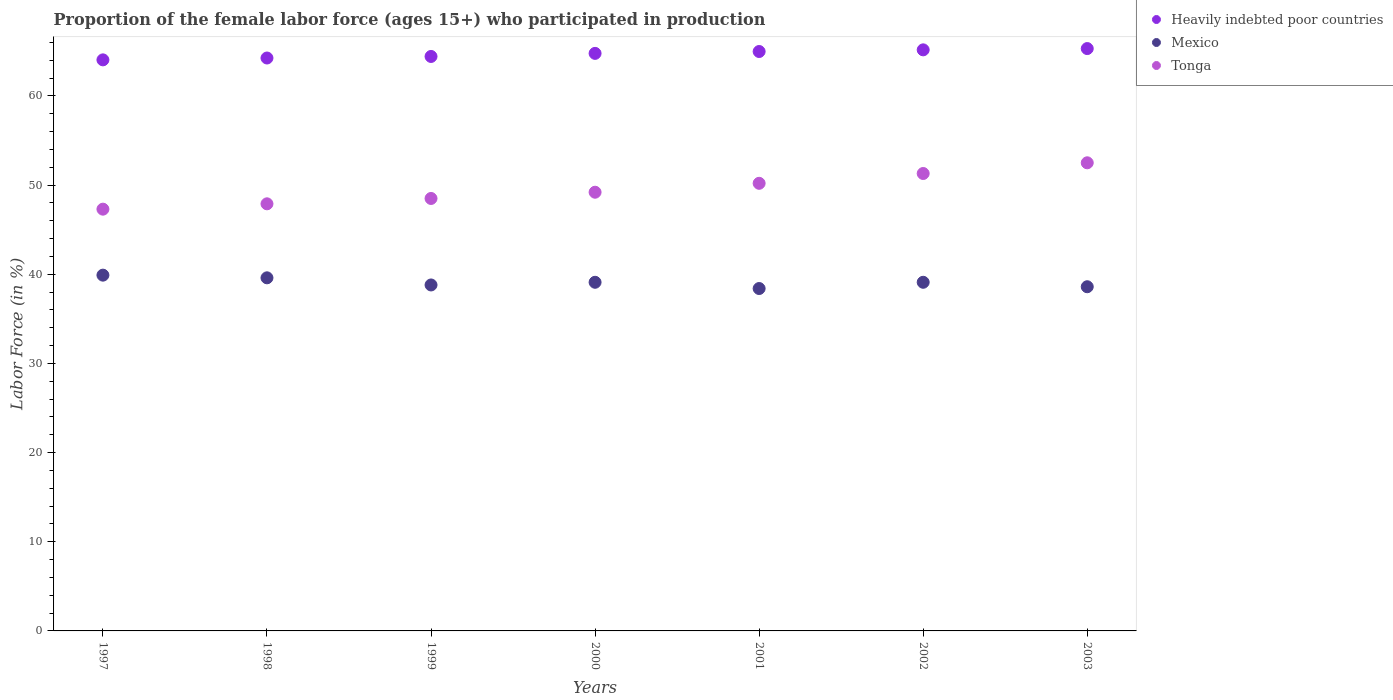Is the number of dotlines equal to the number of legend labels?
Provide a short and direct response. Yes. What is the proportion of the female labor force who participated in production in Tonga in 2002?
Offer a terse response. 51.3. Across all years, what is the maximum proportion of the female labor force who participated in production in Tonga?
Give a very brief answer. 52.5. Across all years, what is the minimum proportion of the female labor force who participated in production in Mexico?
Your answer should be compact. 38.4. What is the total proportion of the female labor force who participated in production in Heavily indebted poor countries in the graph?
Give a very brief answer. 452.95. What is the difference between the proportion of the female labor force who participated in production in Heavily indebted poor countries in 2000 and that in 2002?
Your answer should be compact. -0.4. What is the difference between the proportion of the female labor force who participated in production in Heavily indebted poor countries in 2001 and the proportion of the female labor force who participated in production in Tonga in 2000?
Give a very brief answer. 15.78. What is the average proportion of the female labor force who participated in production in Tonga per year?
Offer a terse response. 49.56. In the year 2000, what is the difference between the proportion of the female labor force who participated in production in Tonga and proportion of the female labor force who participated in production in Heavily indebted poor countries?
Provide a succinct answer. -15.57. In how many years, is the proportion of the female labor force who participated in production in Mexico greater than 36 %?
Provide a short and direct response. 7. What is the ratio of the proportion of the female labor force who participated in production in Tonga in 1999 to that in 2000?
Ensure brevity in your answer.  0.99. Is the proportion of the female labor force who participated in production in Tonga in 2001 less than that in 2003?
Offer a very short reply. Yes. Is the difference between the proportion of the female labor force who participated in production in Tonga in 1998 and 1999 greater than the difference between the proportion of the female labor force who participated in production in Heavily indebted poor countries in 1998 and 1999?
Make the answer very short. No. What is the difference between the highest and the second highest proportion of the female labor force who participated in production in Mexico?
Your answer should be very brief. 0.3. What is the difference between the highest and the lowest proportion of the female labor force who participated in production in Heavily indebted poor countries?
Provide a short and direct response. 1.27. In how many years, is the proportion of the female labor force who participated in production in Mexico greater than the average proportion of the female labor force who participated in production in Mexico taken over all years?
Make the answer very short. 4. How many dotlines are there?
Your response must be concise. 3. Are the values on the major ticks of Y-axis written in scientific E-notation?
Provide a short and direct response. No. Does the graph contain any zero values?
Your answer should be compact. No. Where does the legend appear in the graph?
Your response must be concise. Top right. How are the legend labels stacked?
Your response must be concise. Vertical. What is the title of the graph?
Make the answer very short. Proportion of the female labor force (ages 15+) who participated in production. What is the Labor Force (in %) in Heavily indebted poor countries in 1997?
Your answer should be very brief. 64.04. What is the Labor Force (in %) of Mexico in 1997?
Keep it short and to the point. 39.9. What is the Labor Force (in %) in Tonga in 1997?
Offer a very short reply. 47.3. What is the Labor Force (in %) of Heavily indebted poor countries in 1998?
Ensure brevity in your answer.  64.25. What is the Labor Force (in %) in Mexico in 1998?
Your answer should be very brief. 39.6. What is the Labor Force (in %) of Tonga in 1998?
Ensure brevity in your answer.  47.9. What is the Labor Force (in %) of Heavily indebted poor countries in 1999?
Provide a short and direct response. 64.43. What is the Labor Force (in %) of Mexico in 1999?
Your answer should be very brief. 38.8. What is the Labor Force (in %) of Tonga in 1999?
Offer a terse response. 48.5. What is the Labor Force (in %) in Heavily indebted poor countries in 2000?
Keep it short and to the point. 64.77. What is the Labor Force (in %) of Mexico in 2000?
Your answer should be very brief. 39.1. What is the Labor Force (in %) of Tonga in 2000?
Your answer should be very brief. 49.2. What is the Labor Force (in %) in Heavily indebted poor countries in 2001?
Give a very brief answer. 64.98. What is the Labor Force (in %) in Mexico in 2001?
Your answer should be compact. 38.4. What is the Labor Force (in %) in Tonga in 2001?
Your response must be concise. 50.2. What is the Labor Force (in %) in Heavily indebted poor countries in 2002?
Give a very brief answer. 65.17. What is the Labor Force (in %) of Mexico in 2002?
Provide a succinct answer. 39.1. What is the Labor Force (in %) of Tonga in 2002?
Give a very brief answer. 51.3. What is the Labor Force (in %) in Heavily indebted poor countries in 2003?
Your response must be concise. 65.31. What is the Labor Force (in %) of Mexico in 2003?
Provide a short and direct response. 38.6. What is the Labor Force (in %) of Tonga in 2003?
Provide a succinct answer. 52.5. Across all years, what is the maximum Labor Force (in %) of Heavily indebted poor countries?
Provide a short and direct response. 65.31. Across all years, what is the maximum Labor Force (in %) of Mexico?
Your answer should be compact. 39.9. Across all years, what is the maximum Labor Force (in %) of Tonga?
Give a very brief answer. 52.5. Across all years, what is the minimum Labor Force (in %) in Heavily indebted poor countries?
Offer a terse response. 64.04. Across all years, what is the minimum Labor Force (in %) in Mexico?
Offer a terse response. 38.4. Across all years, what is the minimum Labor Force (in %) in Tonga?
Make the answer very short. 47.3. What is the total Labor Force (in %) of Heavily indebted poor countries in the graph?
Ensure brevity in your answer.  452.95. What is the total Labor Force (in %) in Mexico in the graph?
Your response must be concise. 273.5. What is the total Labor Force (in %) of Tonga in the graph?
Your answer should be very brief. 346.9. What is the difference between the Labor Force (in %) of Heavily indebted poor countries in 1997 and that in 1998?
Provide a succinct answer. -0.21. What is the difference between the Labor Force (in %) of Tonga in 1997 and that in 1998?
Make the answer very short. -0.6. What is the difference between the Labor Force (in %) in Heavily indebted poor countries in 1997 and that in 1999?
Your response must be concise. -0.38. What is the difference between the Labor Force (in %) of Mexico in 1997 and that in 1999?
Ensure brevity in your answer.  1.1. What is the difference between the Labor Force (in %) in Heavily indebted poor countries in 1997 and that in 2000?
Offer a terse response. -0.73. What is the difference between the Labor Force (in %) in Tonga in 1997 and that in 2000?
Give a very brief answer. -1.9. What is the difference between the Labor Force (in %) in Heavily indebted poor countries in 1997 and that in 2001?
Make the answer very short. -0.94. What is the difference between the Labor Force (in %) in Mexico in 1997 and that in 2001?
Make the answer very short. 1.5. What is the difference between the Labor Force (in %) of Heavily indebted poor countries in 1997 and that in 2002?
Offer a very short reply. -1.12. What is the difference between the Labor Force (in %) of Mexico in 1997 and that in 2002?
Your response must be concise. 0.8. What is the difference between the Labor Force (in %) in Tonga in 1997 and that in 2002?
Make the answer very short. -4. What is the difference between the Labor Force (in %) in Heavily indebted poor countries in 1997 and that in 2003?
Offer a very short reply. -1.27. What is the difference between the Labor Force (in %) in Mexico in 1997 and that in 2003?
Provide a short and direct response. 1.3. What is the difference between the Labor Force (in %) of Heavily indebted poor countries in 1998 and that in 1999?
Offer a terse response. -0.17. What is the difference between the Labor Force (in %) in Tonga in 1998 and that in 1999?
Offer a very short reply. -0.6. What is the difference between the Labor Force (in %) in Heavily indebted poor countries in 1998 and that in 2000?
Make the answer very short. -0.52. What is the difference between the Labor Force (in %) of Tonga in 1998 and that in 2000?
Ensure brevity in your answer.  -1.3. What is the difference between the Labor Force (in %) of Heavily indebted poor countries in 1998 and that in 2001?
Provide a succinct answer. -0.73. What is the difference between the Labor Force (in %) in Heavily indebted poor countries in 1998 and that in 2002?
Provide a succinct answer. -0.92. What is the difference between the Labor Force (in %) of Tonga in 1998 and that in 2002?
Give a very brief answer. -3.4. What is the difference between the Labor Force (in %) of Heavily indebted poor countries in 1998 and that in 2003?
Give a very brief answer. -1.06. What is the difference between the Labor Force (in %) in Mexico in 1998 and that in 2003?
Ensure brevity in your answer.  1. What is the difference between the Labor Force (in %) of Tonga in 1998 and that in 2003?
Provide a short and direct response. -4.6. What is the difference between the Labor Force (in %) of Heavily indebted poor countries in 1999 and that in 2000?
Offer a very short reply. -0.35. What is the difference between the Labor Force (in %) in Tonga in 1999 and that in 2000?
Ensure brevity in your answer.  -0.7. What is the difference between the Labor Force (in %) in Heavily indebted poor countries in 1999 and that in 2001?
Offer a very short reply. -0.56. What is the difference between the Labor Force (in %) in Mexico in 1999 and that in 2001?
Provide a succinct answer. 0.4. What is the difference between the Labor Force (in %) in Tonga in 1999 and that in 2001?
Offer a terse response. -1.7. What is the difference between the Labor Force (in %) of Heavily indebted poor countries in 1999 and that in 2002?
Give a very brief answer. -0.74. What is the difference between the Labor Force (in %) in Mexico in 1999 and that in 2002?
Provide a succinct answer. -0.3. What is the difference between the Labor Force (in %) of Tonga in 1999 and that in 2002?
Keep it short and to the point. -2.8. What is the difference between the Labor Force (in %) in Heavily indebted poor countries in 1999 and that in 2003?
Offer a very short reply. -0.88. What is the difference between the Labor Force (in %) of Tonga in 1999 and that in 2003?
Your answer should be very brief. -4. What is the difference between the Labor Force (in %) of Heavily indebted poor countries in 2000 and that in 2001?
Your response must be concise. -0.21. What is the difference between the Labor Force (in %) in Tonga in 2000 and that in 2001?
Provide a short and direct response. -1. What is the difference between the Labor Force (in %) of Heavily indebted poor countries in 2000 and that in 2002?
Provide a succinct answer. -0.4. What is the difference between the Labor Force (in %) in Tonga in 2000 and that in 2002?
Your answer should be very brief. -2.1. What is the difference between the Labor Force (in %) in Heavily indebted poor countries in 2000 and that in 2003?
Provide a short and direct response. -0.54. What is the difference between the Labor Force (in %) in Mexico in 2000 and that in 2003?
Provide a succinct answer. 0.5. What is the difference between the Labor Force (in %) in Tonga in 2000 and that in 2003?
Your response must be concise. -3.3. What is the difference between the Labor Force (in %) of Heavily indebted poor countries in 2001 and that in 2002?
Your answer should be very brief. -0.19. What is the difference between the Labor Force (in %) in Heavily indebted poor countries in 2001 and that in 2003?
Give a very brief answer. -0.33. What is the difference between the Labor Force (in %) of Tonga in 2001 and that in 2003?
Offer a terse response. -2.3. What is the difference between the Labor Force (in %) in Heavily indebted poor countries in 2002 and that in 2003?
Your response must be concise. -0.14. What is the difference between the Labor Force (in %) in Heavily indebted poor countries in 1997 and the Labor Force (in %) in Mexico in 1998?
Offer a terse response. 24.44. What is the difference between the Labor Force (in %) of Heavily indebted poor countries in 1997 and the Labor Force (in %) of Tonga in 1998?
Offer a very short reply. 16.14. What is the difference between the Labor Force (in %) of Heavily indebted poor countries in 1997 and the Labor Force (in %) of Mexico in 1999?
Your answer should be very brief. 25.24. What is the difference between the Labor Force (in %) in Heavily indebted poor countries in 1997 and the Labor Force (in %) in Tonga in 1999?
Make the answer very short. 15.54. What is the difference between the Labor Force (in %) in Mexico in 1997 and the Labor Force (in %) in Tonga in 1999?
Your response must be concise. -8.6. What is the difference between the Labor Force (in %) in Heavily indebted poor countries in 1997 and the Labor Force (in %) in Mexico in 2000?
Provide a short and direct response. 24.94. What is the difference between the Labor Force (in %) in Heavily indebted poor countries in 1997 and the Labor Force (in %) in Tonga in 2000?
Offer a terse response. 14.84. What is the difference between the Labor Force (in %) of Heavily indebted poor countries in 1997 and the Labor Force (in %) of Mexico in 2001?
Give a very brief answer. 25.64. What is the difference between the Labor Force (in %) in Heavily indebted poor countries in 1997 and the Labor Force (in %) in Tonga in 2001?
Provide a short and direct response. 13.84. What is the difference between the Labor Force (in %) of Heavily indebted poor countries in 1997 and the Labor Force (in %) of Mexico in 2002?
Your answer should be compact. 24.94. What is the difference between the Labor Force (in %) in Heavily indebted poor countries in 1997 and the Labor Force (in %) in Tonga in 2002?
Your answer should be very brief. 12.74. What is the difference between the Labor Force (in %) of Heavily indebted poor countries in 1997 and the Labor Force (in %) of Mexico in 2003?
Your answer should be compact. 25.44. What is the difference between the Labor Force (in %) of Heavily indebted poor countries in 1997 and the Labor Force (in %) of Tonga in 2003?
Provide a succinct answer. 11.54. What is the difference between the Labor Force (in %) in Mexico in 1997 and the Labor Force (in %) in Tonga in 2003?
Make the answer very short. -12.6. What is the difference between the Labor Force (in %) in Heavily indebted poor countries in 1998 and the Labor Force (in %) in Mexico in 1999?
Your answer should be compact. 25.45. What is the difference between the Labor Force (in %) in Heavily indebted poor countries in 1998 and the Labor Force (in %) in Tonga in 1999?
Provide a succinct answer. 15.75. What is the difference between the Labor Force (in %) in Mexico in 1998 and the Labor Force (in %) in Tonga in 1999?
Ensure brevity in your answer.  -8.9. What is the difference between the Labor Force (in %) of Heavily indebted poor countries in 1998 and the Labor Force (in %) of Mexico in 2000?
Your response must be concise. 25.15. What is the difference between the Labor Force (in %) of Heavily indebted poor countries in 1998 and the Labor Force (in %) of Tonga in 2000?
Offer a terse response. 15.05. What is the difference between the Labor Force (in %) in Heavily indebted poor countries in 1998 and the Labor Force (in %) in Mexico in 2001?
Your response must be concise. 25.85. What is the difference between the Labor Force (in %) in Heavily indebted poor countries in 1998 and the Labor Force (in %) in Tonga in 2001?
Ensure brevity in your answer.  14.05. What is the difference between the Labor Force (in %) in Mexico in 1998 and the Labor Force (in %) in Tonga in 2001?
Your response must be concise. -10.6. What is the difference between the Labor Force (in %) of Heavily indebted poor countries in 1998 and the Labor Force (in %) of Mexico in 2002?
Your answer should be compact. 25.15. What is the difference between the Labor Force (in %) of Heavily indebted poor countries in 1998 and the Labor Force (in %) of Tonga in 2002?
Offer a terse response. 12.95. What is the difference between the Labor Force (in %) in Heavily indebted poor countries in 1998 and the Labor Force (in %) in Mexico in 2003?
Provide a short and direct response. 25.65. What is the difference between the Labor Force (in %) in Heavily indebted poor countries in 1998 and the Labor Force (in %) in Tonga in 2003?
Ensure brevity in your answer.  11.75. What is the difference between the Labor Force (in %) in Mexico in 1998 and the Labor Force (in %) in Tonga in 2003?
Make the answer very short. -12.9. What is the difference between the Labor Force (in %) of Heavily indebted poor countries in 1999 and the Labor Force (in %) of Mexico in 2000?
Make the answer very short. 25.33. What is the difference between the Labor Force (in %) in Heavily indebted poor countries in 1999 and the Labor Force (in %) in Tonga in 2000?
Ensure brevity in your answer.  15.23. What is the difference between the Labor Force (in %) of Heavily indebted poor countries in 1999 and the Labor Force (in %) of Mexico in 2001?
Offer a terse response. 26.03. What is the difference between the Labor Force (in %) in Heavily indebted poor countries in 1999 and the Labor Force (in %) in Tonga in 2001?
Keep it short and to the point. 14.23. What is the difference between the Labor Force (in %) in Mexico in 1999 and the Labor Force (in %) in Tonga in 2001?
Your answer should be compact. -11.4. What is the difference between the Labor Force (in %) of Heavily indebted poor countries in 1999 and the Labor Force (in %) of Mexico in 2002?
Your answer should be compact. 25.33. What is the difference between the Labor Force (in %) of Heavily indebted poor countries in 1999 and the Labor Force (in %) of Tonga in 2002?
Your response must be concise. 13.13. What is the difference between the Labor Force (in %) in Heavily indebted poor countries in 1999 and the Labor Force (in %) in Mexico in 2003?
Offer a very short reply. 25.83. What is the difference between the Labor Force (in %) in Heavily indebted poor countries in 1999 and the Labor Force (in %) in Tonga in 2003?
Provide a succinct answer. 11.93. What is the difference between the Labor Force (in %) in Mexico in 1999 and the Labor Force (in %) in Tonga in 2003?
Ensure brevity in your answer.  -13.7. What is the difference between the Labor Force (in %) in Heavily indebted poor countries in 2000 and the Labor Force (in %) in Mexico in 2001?
Your answer should be very brief. 26.37. What is the difference between the Labor Force (in %) in Heavily indebted poor countries in 2000 and the Labor Force (in %) in Tonga in 2001?
Offer a terse response. 14.57. What is the difference between the Labor Force (in %) in Heavily indebted poor countries in 2000 and the Labor Force (in %) in Mexico in 2002?
Provide a short and direct response. 25.67. What is the difference between the Labor Force (in %) of Heavily indebted poor countries in 2000 and the Labor Force (in %) of Tonga in 2002?
Keep it short and to the point. 13.47. What is the difference between the Labor Force (in %) of Mexico in 2000 and the Labor Force (in %) of Tonga in 2002?
Make the answer very short. -12.2. What is the difference between the Labor Force (in %) of Heavily indebted poor countries in 2000 and the Labor Force (in %) of Mexico in 2003?
Provide a succinct answer. 26.17. What is the difference between the Labor Force (in %) of Heavily indebted poor countries in 2000 and the Labor Force (in %) of Tonga in 2003?
Offer a terse response. 12.27. What is the difference between the Labor Force (in %) of Mexico in 2000 and the Labor Force (in %) of Tonga in 2003?
Your response must be concise. -13.4. What is the difference between the Labor Force (in %) in Heavily indebted poor countries in 2001 and the Labor Force (in %) in Mexico in 2002?
Your response must be concise. 25.88. What is the difference between the Labor Force (in %) in Heavily indebted poor countries in 2001 and the Labor Force (in %) in Tonga in 2002?
Provide a succinct answer. 13.68. What is the difference between the Labor Force (in %) of Heavily indebted poor countries in 2001 and the Labor Force (in %) of Mexico in 2003?
Your answer should be very brief. 26.38. What is the difference between the Labor Force (in %) of Heavily indebted poor countries in 2001 and the Labor Force (in %) of Tonga in 2003?
Offer a very short reply. 12.48. What is the difference between the Labor Force (in %) of Mexico in 2001 and the Labor Force (in %) of Tonga in 2003?
Your response must be concise. -14.1. What is the difference between the Labor Force (in %) of Heavily indebted poor countries in 2002 and the Labor Force (in %) of Mexico in 2003?
Provide a short and direct response. 26.57. What is the difference between the Labor Force (in %) of Heavily indebted poor countries in 2002 and the Labor Force (in %) of Tonga in 2003?
Offer a terse response. 12.67. What is the difference between the Labor Force (in %) of Mexico in 2002 and the Labor Force (in %) of Tonga in 2003?
Provide a succinct answer. -13.4. What is the average Labor Force (in %) in Heavily indebted poor countries per year?
Your answer should be compact. 64.71. What is the average Labor Force (in %) of Mexico per year?
Provide a succinct answer. 39.07. What is the average Labor Force (in %) of Tonga per year?
Your response must be concise. 49.56. In the year 1997, what is the difference between the Labor Force (in %) of Heavily indebted poor countries and Labor Force (in %) of Mexico?
Your answer should be compact. 24.14. In the year 1997, what is the difference between the Labor Force (in %) of Heavily indebted poor countries and Labor Force (in %) of Tonga?
Make the answer very short. 16.74. In the year 1998, what is the difference between the Labor Force (in %) in Heavily indebted poor countries and Labor Force (in %) in Mexico?
Your answer should be very brief. 24.65. In the year 1998, what is the difference between the Labor Force (in %) of Heavily indebted poor countries and Labor Force (in %) of Tonga?
Provide a short and direct response. 16.35. In the year 1998, what is the difference between the Labor Force (in %) of Mexico and Labor Force (in %) of Tonga?
Your answer should be compact. -8.3. In the year 1999, what is the difference between the Labor Force (in %) in Heavily indebted poor countries and Labor Force (in %) in Mexico?
Your answer should be compact. 25.63. In the year 1999, what is the difference between the Labor Force (in %) in Heavily indebted poor countries and Labor Force (in %) in Tonga?
Provide a short and direct response. 15.93. In the year 2000, what is the difference between the Labor Force (in %) in Heavily indebted poor countries and Labor Force (in %) in Mexico?
Offer a very short reply. 25.67. In the year 2000, what is the difference between the Labor Force (in %) in Heavily indebted poor countries and Labor Force (in %) in Tonga?
Make the answer very short. 15.57. In the year 2000, what is the difference between the Labor Force (in %) of Mexico and Labor Force (in %) of Tonga?
Make the answer very short. -10.1. In the year 2001, what is the difference between the Labor Force (in %) of Heavily indebted poor countries and Labor Force (in %) of Mexico?
Give a very brief answer. 26.58. In the year 2001, what is the difference between the Labor Force (in %) of Heavily indebted poor countries and Labor Force (in %) of Tonga?
Provide a succinct answer. 14.78. In the year 2001, what is the difference between the Labor Force (in %) of Mexico and Labor Force (in %) of Tonga?
Keep it short and to the point. -11.8. In the year 2002, what is the difference between the Labor Force (in %) of Heavily indebted poor countries and Labor Force (in %) of Mexico?
Make the answer very short. 26.07. In the year 2002, what is the difference between the Labor Force (in %) of Heavily indebted poor countries and Labor Force (in %) of Tonga?
Offer a terse response. 13.87. In the year 2002, what is the difference between the Labor Force (in %) of Mexico and Labor Force (in %) of Tonga?
Keep it short and to the point. -12.2. In the year 2003, what is the difference between the Labor Force (in %) in Heavily indebted poor countries and Labor Force (in %) in Mexico?
Your response must be concise. 26.71. In the year 2003, what is the difference between the Labor Force (in %) of Heavily indebted poor countries and Labor Force (in %) of Tonga?
Keep it short and to the point. 12.81. In the year 2003, what is the difference between the Labor Force (in %) of Mexico and Labor Force (in %) of Tonga?
Ensure brevity in your answer.  -13.9. What is the ratio of the Labor Force (in %) in Mexico in 1997 to that in 1998?
Your answer should be very brief. 1.01. What is the ratio of the Labor Force (in %) of Tonga in 1997 to that in 1998?
Give a very brief answer. 0.99. What is the ratio of the Labor Force (in %) in Mexico in 1997 to that in 1999?
Your response must be concise. 1.03. What is the ratio of the Labor Force (in %) in Tonga in 1997 to that in 1999?
Give a very brief answer. 0.98. What is the ratio of the Labor Force (in %) in Heavily indebted poor countries in 1997 to that in 2000?
Offer a very short reply. 0.99. What is the ratio of the Labor Force (in %) of Mexico in 1997 to that in 2000?
Offer a terse response. 1.02. What is the ratio of the Labor Force (in %) of Tonga in 1997 to that in 2000?
Provide a succinct answer. 0.96. What is the ratio of the Labor Force (in %) of Heavily indebted poor countries in 1997 to that in 2001?
Provide a short and direct response. 0.99. What is the ratio of the Labor Force (in %) of Mexico in 1997 to that in 2001?
Give a very brief answer. 1.04. What is the ratio of the Labor Force (in %) of Tonga in 1997 to that in 2001?
Offer a very short reply. 0.94. What is the ratio of the Labor Force (in %) of Heavily indebted poor countries in 1997 to that in 2002?
Ensure brevity in your answer.  0.98. What is the ratio of the Labor Force (in %) of Mexico in 1997 to that in 2002?
Provide a succinct answer. 1.02. What is the ratio of the Labor Force (in %) in Tonga in 1997 to that in 2002?
Give a very brief answer. 0.92. What is the ratio of the Labor Force (in %) in Heavily indebted poor countries in 1997 to that in 2003?
Keep it short and to the point. 0.98. What is the ratio of the Labor Force (in %) in Mexico in 1997 to that in 2003?
Offer a terse response. 1.03. What is the ratio of the Labor Force (in %) of Tonga in 1997 to that in 2003?
Make the answer very short. 0.9. What is the ratio of the Labor Force (in %) of Heavily indebted poor countries in 1998 to that in 1999?
Offer a terse response. 1. What is the ratio of the Labor Force (in %) of Mexico in 1998 to that in 1999?
Your answer should be compact. 1.02. What is the ratio of the Labor Force (in %) in Tonga in 1998 to that in 1999?
Make the answer very short. 0.99. What is the ratio of the Labor Force (in %) of Mexico in 1998 to that in 2000?
Offer a very short reply. 1.01. What is the ratio of the Labor Force (in %) in Tonga in 1998 to that in 2000?
Your response must be concise. 0.97. What is the ratio of the Labor Force (in %) in Mexico in 1998 to that in 2001?
Ensure brevity in your answer.  1.03. What is the ratio of the Labor Force (in %) in Tonga in 1998 to that in 2001?
Your answer should be compact. 0.95. What is the ratio of the Labor Force (in %) in Heavily indebted poor countries in 1998 to that in 2002?
Make the answer very short. 0.99. What is the ratio of the Labor Force (in %) of Mexico in 1998 to that in 2002?
Make the answer very short. 1.01. What is the ratio of the Labor Force (in %) of Tonga in 1998 to that in 2002?
Provide a succinct answer. 0.93. What is the ratio of the Labor Force (in %) of Heavily indebted poor countries in 1998 to that in 2003?
Offer a terse response. 0.98. What is the ratio of the Labor Force (in %) of Mexico in 1998 to that in 2003?
Your answer should be compact. 1.03. What is the ratio of the Labor Force (in %) in Tonga in 1998 to that in 2003?
Your answer should be compact. 0.91. What is the ratio of the Labor Force (in %) in Heavily indebted poor countries in 1999 to that in 2000?
Your answer should be compact. 0.99. What is the ratio of the Labor Force (in %) of Mexico in 1999 to that in 2000?
Your answer should be very brief. 0.99. What is the ratio of the Labor Force (in %) in Tonga in 1999 to that in 2000?
Give a very brief answer. 0.99. What is the ratio of the Labor Force (in %) of Heavily indebted poor countries in 1999 to that in 2001?
Make the answer very short. 0.99. What is the ratio of the Labor Force (in %) in Mexico in 1999 to that in 2001?
Give a very brief answer. 1.01. What is the ratio of the Labor Force (in %) of Tonga in 1999 to that in 2001?
Offer a terse response. 0.97. What is the ratio of the Labor Force (in %) of Tonga in 1999 to that in 2002?
Provide a succinct answer. 0.95. What is the ratio of the Labor Force (in %) in Heavily indebted poor countries in 1999 to that in 2003?
Offer a very short reply. 0.99. What is the ratio of the Labor Force (in %) of Mexico in 1999 to that in 2003?
Offer a very short reply. 1.01. What is the ratio of the Labor Force (in %) in Tonga in 1999 to that in 2003?
Provide a short and direct response. 0.92. What is the ratio of the Labor Force (in %) in Heavily indebted poor countries in 2000 to that in 2001?
Offer a very short reply. 1. What is the ratio of the Labor Force (in %) in Mexico in 2000 to that in 2001?
Offer a terse response. 1.02. What is the ratio of the Labor Force (in %) in Tonga in 2000 to that in 2001?
Make the answer very short. 0.98. What is the ratio of the Labor Force (in %) of Heavily indebted poor countries in 2000 to that in 2002?
Your answer should be compact. 0.99. What is the ratio of the Labor Force (in %) in Mexico in 2000 to that in 2002?
Your response must be concise. 1. What is the ratio of the Labor Force (in %) in Tonga in 2000 to that in 2002?
Provide a short and direct response. 0.96. What is the ratio of the Labor Force (in %) of Heavily indebted poor countries in 2000 to that in 2003?
Your response must be concise. 0.99. What is the ratio of the Labor Force (in %) in Tonga in 2000 to that in 2003?
Your answer should be compact. 0.94. What is the ratio of the Labor Force (in %) in Mexico in 2001 to that in 2002?
Ensure brevity in your answer.  0.98. What is the ratio of the Labor Force (in %) in Tonga in 2001 to that in 2002?
Make the answer very short. 0.98. What is the ratio of the Labor Force (in %) of Heavily indebted poor countries in 2001 to that in 2003?
Keep it short and to the point. 0.99. What is the ratio of the Labor Force (in %) of Tonga in 2001 to that in 2003?
Your response must be concise. 0.96. What is the ratio of the Labor Force (in %) of Heavily indebted poor countries in 2002 to that in 2003?
Your answer should be compact. 1. What is the ratio of the Labor Force (in %) in Mexico in 2002 to that in 2003?
Offer a terse response. 1.01. What is the ratio of the Labor Force (in %) in Tonga in 2002 to that in 2003?
Your answer should be very brief. 0.98. What is the difference between the highest and the second highest Labor Force (in %) in Heavily indebted poor countries?
Offer a terse response. 0.14. What is the difference between the highest and the lowest Labor Force (in %) in Heavily indebted poor countries?
Provide a succinct answer. 1.27. What is the difference between the highest and the lowest Labor Force (in %) of Mexico?
Give a very brief answer. 1.5. 